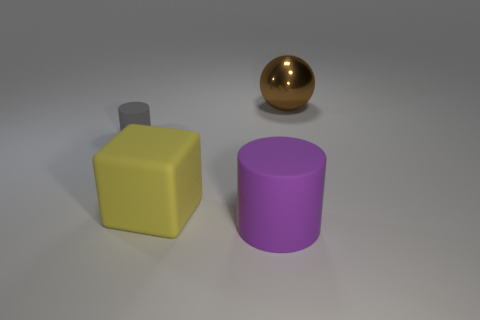Add 2 small gray metal spheres. How many objects exist? 6 Subtract all cubes. Subtract all metallic things. How many objects are left? 2 Add 1 tiny cylinders. How many tiny cylinders are left? 2 Add 2 tiny blue things. How many tiny blue things exist? 2 Subtract all gray cylinders. How many cylinders are left? 1 Subtract 0 red spheres. How many objects are left? 4 Subtract all cubes. How many objects are left? 3 Subtract 1 spheres. How many spheres are left? 0 Subtract all yellow cylinders. Subtract all cyan balls. How many cylinders are left? 2 Subtract all yellow balls. How many gray cylinders are left? 1 